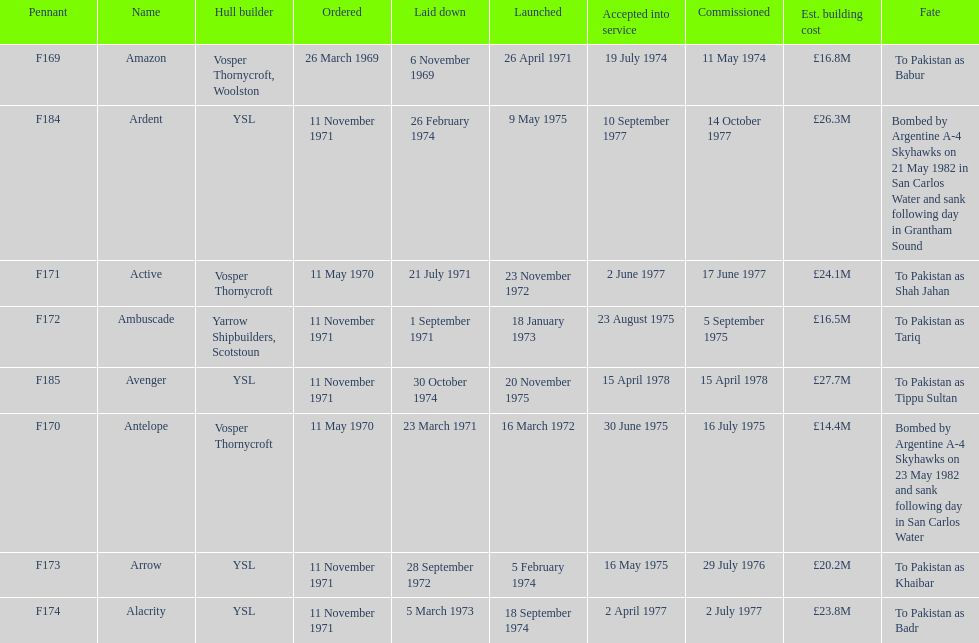Which ship had the highest estimated cost to build? Avenger. 